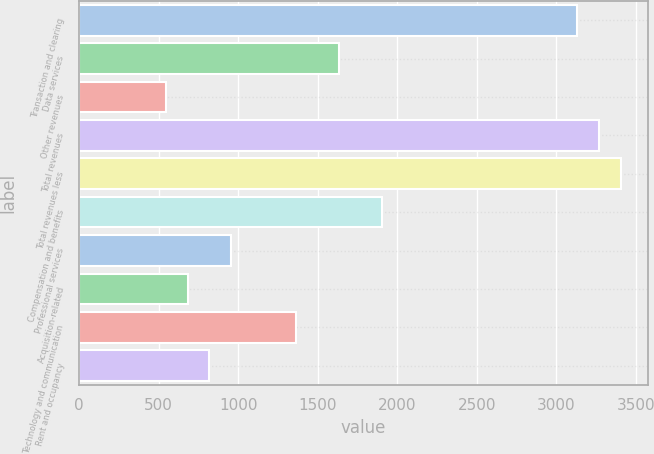Convert chart. <chart><loc_0><loc_0><loc_500><loc_500><bar_chart><fcel>Transaction and clearing<fcel>Data services<fcel>Other revenues<fcel>Total revenues<fcel>Total revenues less<fcel>Compensation and benefits<fcel>Professional services<fcel>Acquisition-related<fcel>Technology and communication<fcel>Rent and occupancy<nl><fcel>3132.95<fcel>1635.3<fcel>546.1<fcel>3269.1<fcel>3405.25<fcel>1907.6<fcel>954.55<fcel>682.25<fcel>1363<fcel>818.4<nl></chart> 